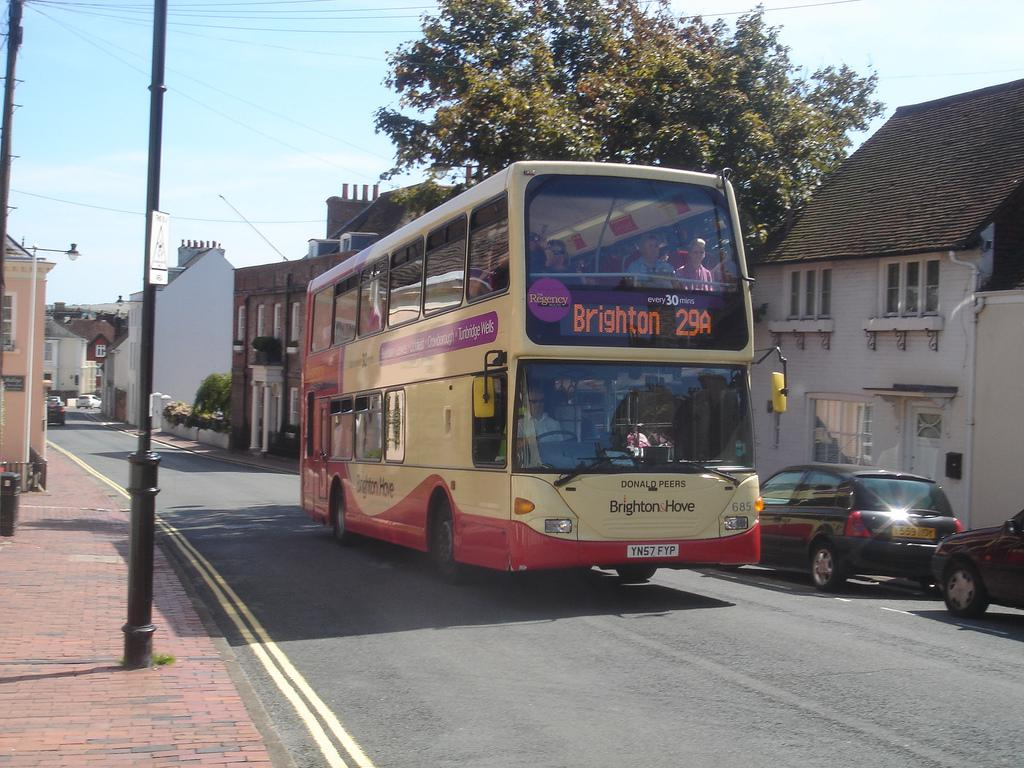Question: what does the bus's sign say?
Choices:
A. Out of service.
B. Cobb 400.
C. Civic Center.
D. Brighton 29a.
Answer with the letter. Answer: D Question: who is driving the bus?
Choices:
A. A bus driver.
B. A passenger.
C. A computer.
D. No one.
Answer with the letter. Answer: A Question: when will the bus pass the pole with the sign on it, close to the curb?
Choices:
A. In about an hour.
B. At the next stop.
C. At the end of its route.
D. Very soon.
Answer with the letter. Answer: D Question: why are the bus doors closed?
Choices:
A. It is in transit, so no one gets on or off.
B. It is in the garage and has no passengers.
C. They are stuck.
D. The bus driver is on strike.
Answer with the letter. Answer: A Question: where are there poles sticking out of?
Choices:
A. The top of the building.
B. The trunk.
C. The cement.
D. The ground.
Answer with the letter. Answer: D Question: what color is the sidewalk?
Choices:
A. Red.
B. White.
C. Gray.
D. Yellow.
Answer with the letter. Answer: A Question: what color is the double line on the side of the street?
Choices:
A. Red.
B. Blue.
C. White.
D. Yellow.
Answer with the letter. Answer: D Question: what is reflecting off the back of a parked car?
Choices:
A. The light.
B. The street lamp.
C. The sun.
D. The rain.
Answer with the letter. Answer: C Question: what does the bus read on the front?
Choices:
A. Cambridge.
B. Brighton.
C. Allston.
D. Arlington.
Answer with the letter. Answer: B Question: what is the large vehicle?
Choices:
A. A van.
B. A motorhome.
C. A fire truck.
D. A bus.
Answer with the letter. Answer: D Question: how many levels does the bus have?
Choices:
A. One.
B. Three.
C. Four.
D. Two.
Answer with the letter. Answer: D Question: what is on the buildings?
Choices:
A. Signs.
B. Banners.
C. Chimneys.
D. Large windows.
Answer with the letter. Answer: C Question: what is in the background?
Choices:
A. People.
B. Animals.
C. Cars.
D. Buildings.
Answer with the letter. Answer: C Question: what color is the roof of the white building?
Choices:
A. Black.
B. Green.
C. Red.
D. Blue.
Answer with the letter. Answer: A Question: where is the white building?
Choices:
A. Near the mall.
B. Across the street.
C. In the capital city.
D. Next to the national bank.
Answer with the letter. Answer: B Question: what kind of bus is it?
Choices:
A. A double-decker bus.
B. A school bus.
C. A tour bus.
D. A city bus.
Answer with the letter. Answer: A 